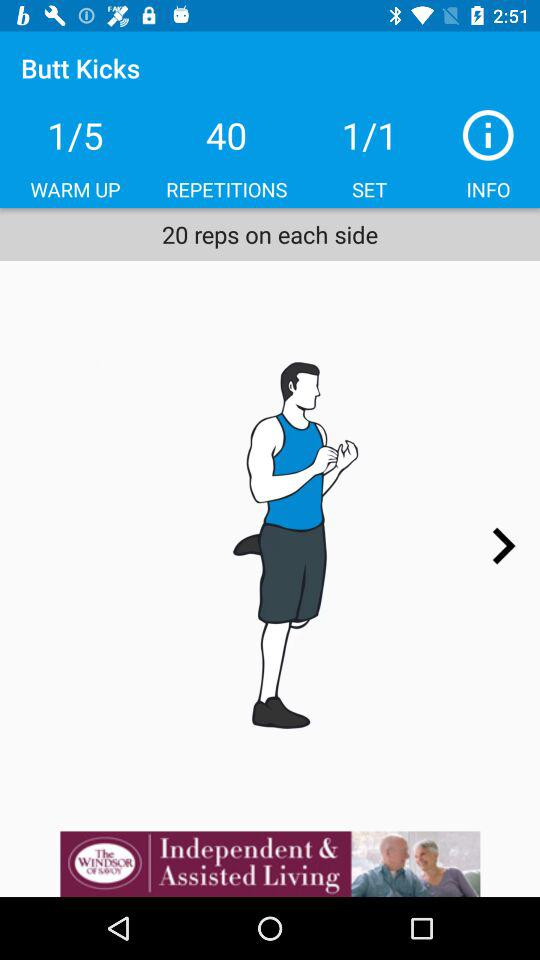What is the number of repetitions on each side? The number of repetitions is 20. 